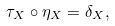<formula> <loc_0><loc_0><loc_500><loc_500>\tau _ { X } \circ \eta _ { X } = \delta _ { X } ,</formula> 